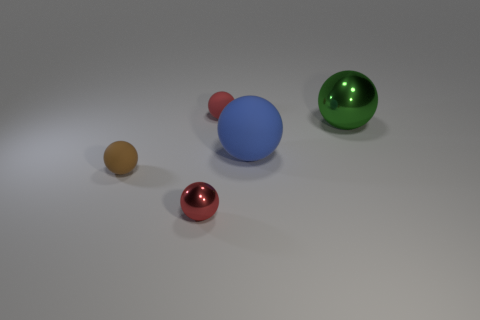Which sphere seems to have the roughest texture? The texture is not very clear from the image, but based on the matt appearance, the largest blue sphere might have the roughest texture compared to the shinier spheres. Describe the positions of the spheres in relation to one another. The spheres are spread out, with the green sphere to the right, the large blue sphere slightly to its left and forward, and the red sphere in front of the blue one. The orange and yellow spheres are off to the left, with the yellow one being closer to the viewer. 